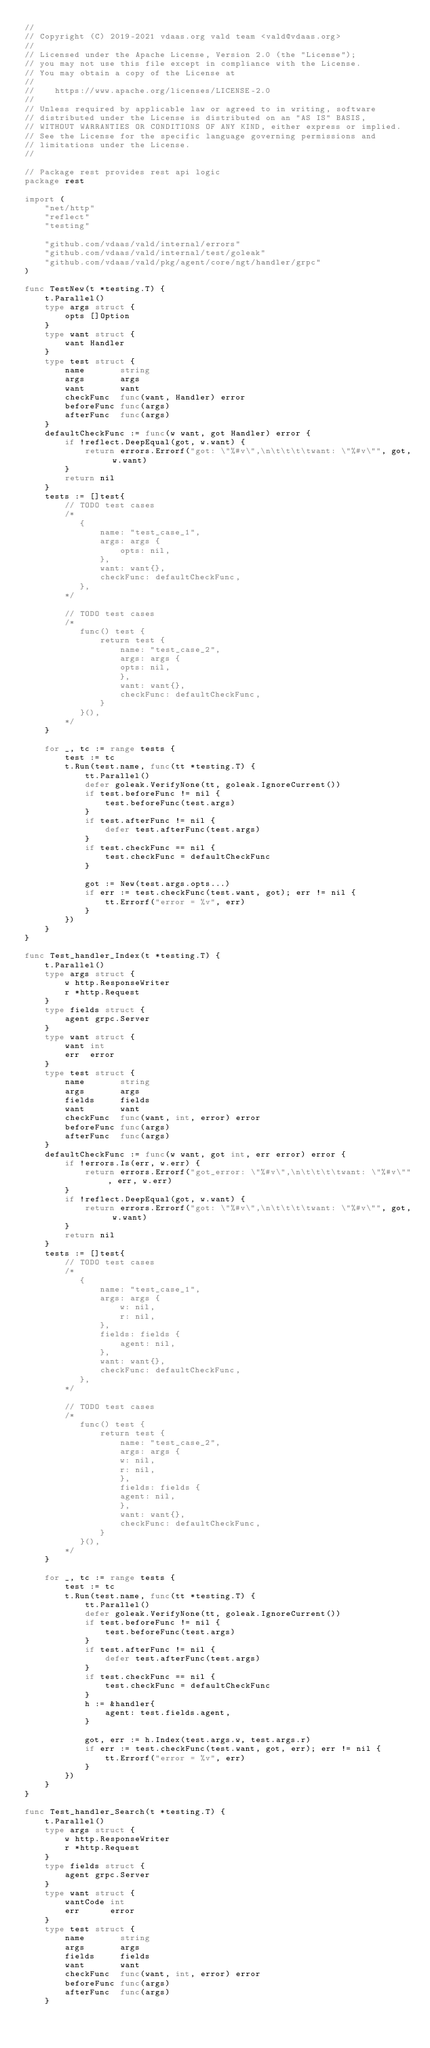Convert code to text. <code><loc_0><loc_0><loc_500><loc_500><_Go_>//
// Copyright (C) 2019-2021 vdaas.org vald team <vald@vdaas.org>
//
// Licensed under the Apache License, Version 2.0 (the "License");
// you may not use this file except in compliance with the License.
// You may obtain a copy of the License at
//
//    https://www.apache.org/licenses/LICENSE-2.0
//
// Unless required by applicable law or agreed to in writing, software
// distributed under the License is distributed on an "AS IS" BASIS,
// WITHOUT WARRANTIES OR CONDITIONS OF ANY KIND, either express or implied.
// See the License for the specific language governing permissions and
// limitations under the License.
//

// Package rest provides rest api logic
package rest

import (
	"net/http"
	"reflect"
	"testing"

	"github.com/vdaas/vald/internal/errors"
	"github.com/vdaas/vald/internal/test/goleak"
	"github.com/vdaas/vald/pkg/agent/core/ngt/handler/grpc"
)

func TestNew(t *testing.T) {
	t.Parallel()
	type args struct {
		opts []Option
	}
	type want struct {
		want Handler
	}
	type test struct {
		name       string
		args       args
		want       want
		checkFunc  func(want, Handler) error
		beforeFunc func(args)
		afterFunc  func(args)
	}
	defaultCheckFunc := func(w want, got Handler) error {
		if !reflect.DeepEqual(got, w.want) {
			return errors.Errorf("got: \"%#v\",\n\t\t\t\twant: \"%#v\"", got, w.want)
		}
		return nil
	}
	tests := []test{
		// TODO test cases
		/*
		   {
		       name: "test_case_1",
		       args: args {
		           opts: nil,
		       },
		       want: want{},
		       checkFunc: defaultCheckFunc,
		   },
		*/

		// TODO test cases
		/*
		   func() test {
		       return test {
		           name: "test_case_2",
		           args: args {
		           opts: nil,
		           },
		           want: want{},
		           checkFunc: defaultCheckFunc,
		       }
		   }(),
		*/
	}

	for _, tc := range tests {
		test := tc
		t.Run(test.name, func(tt *testing.T) {
			tt.Parallel()
			defer goleak.VerifyNone(tt, goleak.IgnoreCurrent())
			if test.beforeFunc != nil {
				test.beforeFunc(test.args)
			}
			if test.afterFunc != nil {
				defer test.afterFunc(test.args)
			}
			if test.checkFunc == nil {
				test.checkFunc = defaultCheckFunc
			}

			got := New(test.args.opts...)
			if err := test.checkFunc(test.want, got); err != nil {
				tt.Errorf("error = %v", err)
			}
		})
	}
}

func Test_handler_Index(t *testing.T) {
	t.Parallel()
	type args struct {
		w http.ResponseWriter
		r *http.Request
	}
	type fields struct {
		agent grpc.Server
	}
	type want struct {
		want int
		err  error
	}
	type test struct {
		name       string
		args       args
		fields     fields
		want       want
		checkFunc  func(want, int, error) error
		beforeFunc func(args)
		afterFunc  func(args)
	}
	defaultCheckFunc := func(w want, got int, err error) error {
		if !errors.Is(err, w.err) {
			return errors.Errorf("got_error: \"%#v\",\n\t\t\t\twant: \"%#v\"", err, w.err)
		}
		if !reflect.DeepEqual(got, w.want) {
			return errors.Errorf("got: \"%#v\",\n\t\t\t\twant: \"%#v\"", got, w.want)
		}
		return nil
	}
	tests := []test{
		// TODO test cases
		/*
		   {
		       name: "test_case_1",
		       args: args {
		           w: nil,
		           r: nil,
		       },
		       fields: fields {
		           agent: nil,
		       },
		       want: want{},
		       checkFunc: defaultCheckFunc,
		   },
		*/

		// TODO test cases
		/*
		   func() test {
		       return test {
		           name: "test_case_2",
		           args: args {
		           w: nil,
		           r: nil,
		           },
		           fields: fields {
		           agent: nil,
		           },
		           want: want{},
		           checkFunc: defaultCheckFunc,
		       }
		   }(),
		*/
	}

	for _, tc := range tests {
		test := tc
		t.Run(test.name, func(tt *testing.T) {
			tt.Parallel()
			defer goleak.VerifyNone(tt, goleak.IgnoreCurrent())
			if test.beforeFunc != nil {
				test.beforeFunc(test.args)
			}
			if test.afterFunc != nil {
				defer test.afterFunc(test.args)
			}
			if test.checkFunc == nil {
				test.checkFunc = defaultCheckFunc
			}
			h := &handler{
				agent: test.fields.agent,
			}

			got, err := h.Index(test.args.w, test.args.r)
			if err := test.checkFunc(test.want, got, err); err != nil {
				tt.Errorf("error = %v", err)
			}
		})
	}
}

func Test_handler_Search(t *testing.T) {
	t.Parallel()
	type args struct {
		w http.ResponseWriter
		r *http.Request
	}
	type fields struct {
		agent grpc.Server
	}
	type want struct {
		wantCode int
		err      error
	}
	type test struct {
		name       string
		args       args
		fields     fields
		want       want
		checkFunc  func(want, int, error) error
		beforeFunc func(args)
		afterFunc  func(args)
	}</code> 